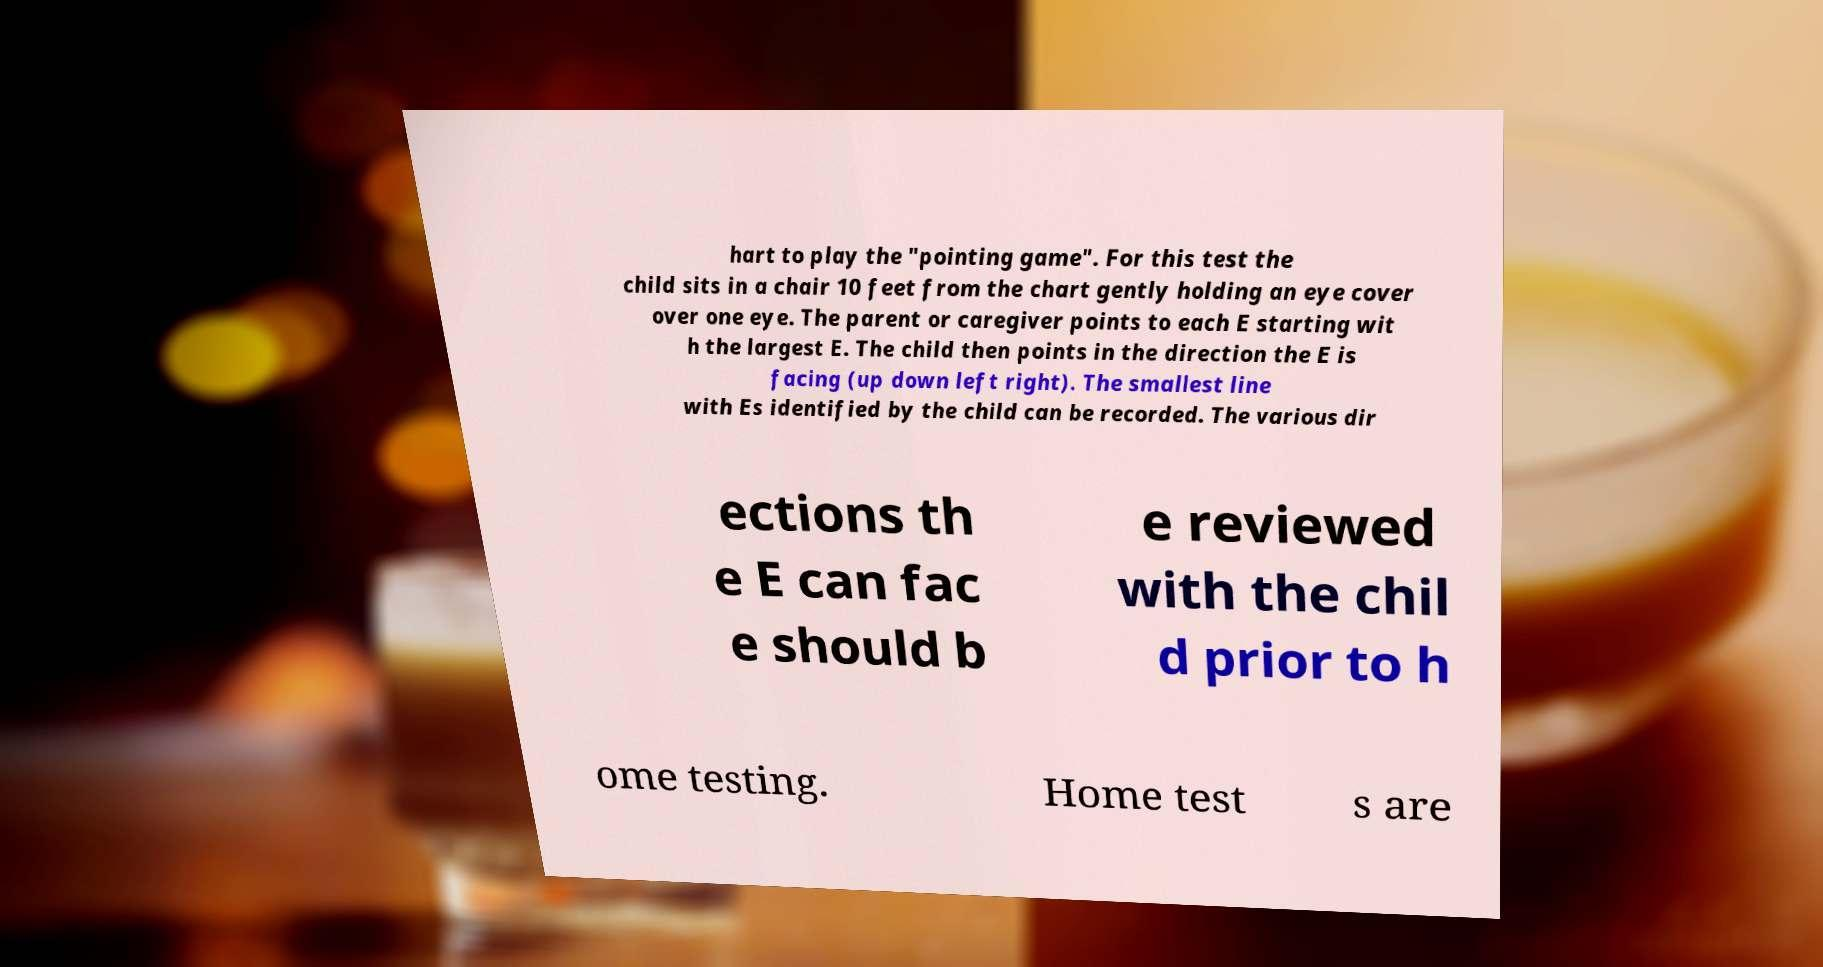There's text embedded in this image that I need extracted. Can you transcribe it verbatim? hart to play the "pointing game". For this test the child sits in a chair 10 feet from the chart gently holding an eye cover over one eye. The parent or caregiver points to each E starting wit h the largest E. The child then points in the direction the E is facing (up down left right). The smallest line with Es identified by the child can be recorded. The various dir ections th e E can fac e should b e reviewed with the chil d prior to h ome testing. Home test s are 